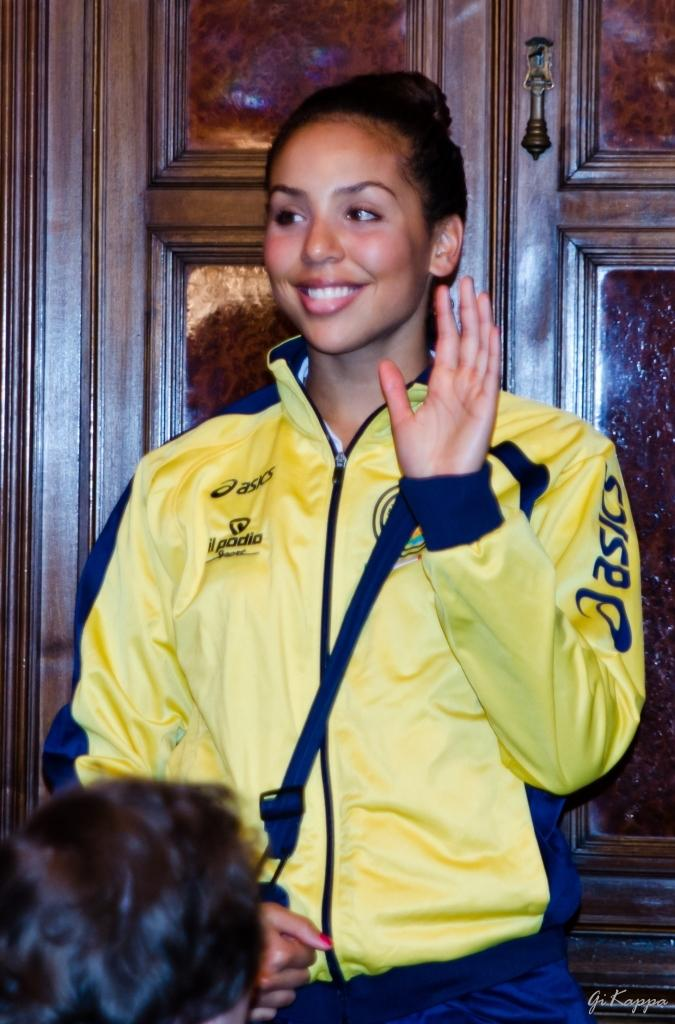<image>
Relay a brief, clear account of the picture shown. woman in yellow asics jacket in front of door waving 